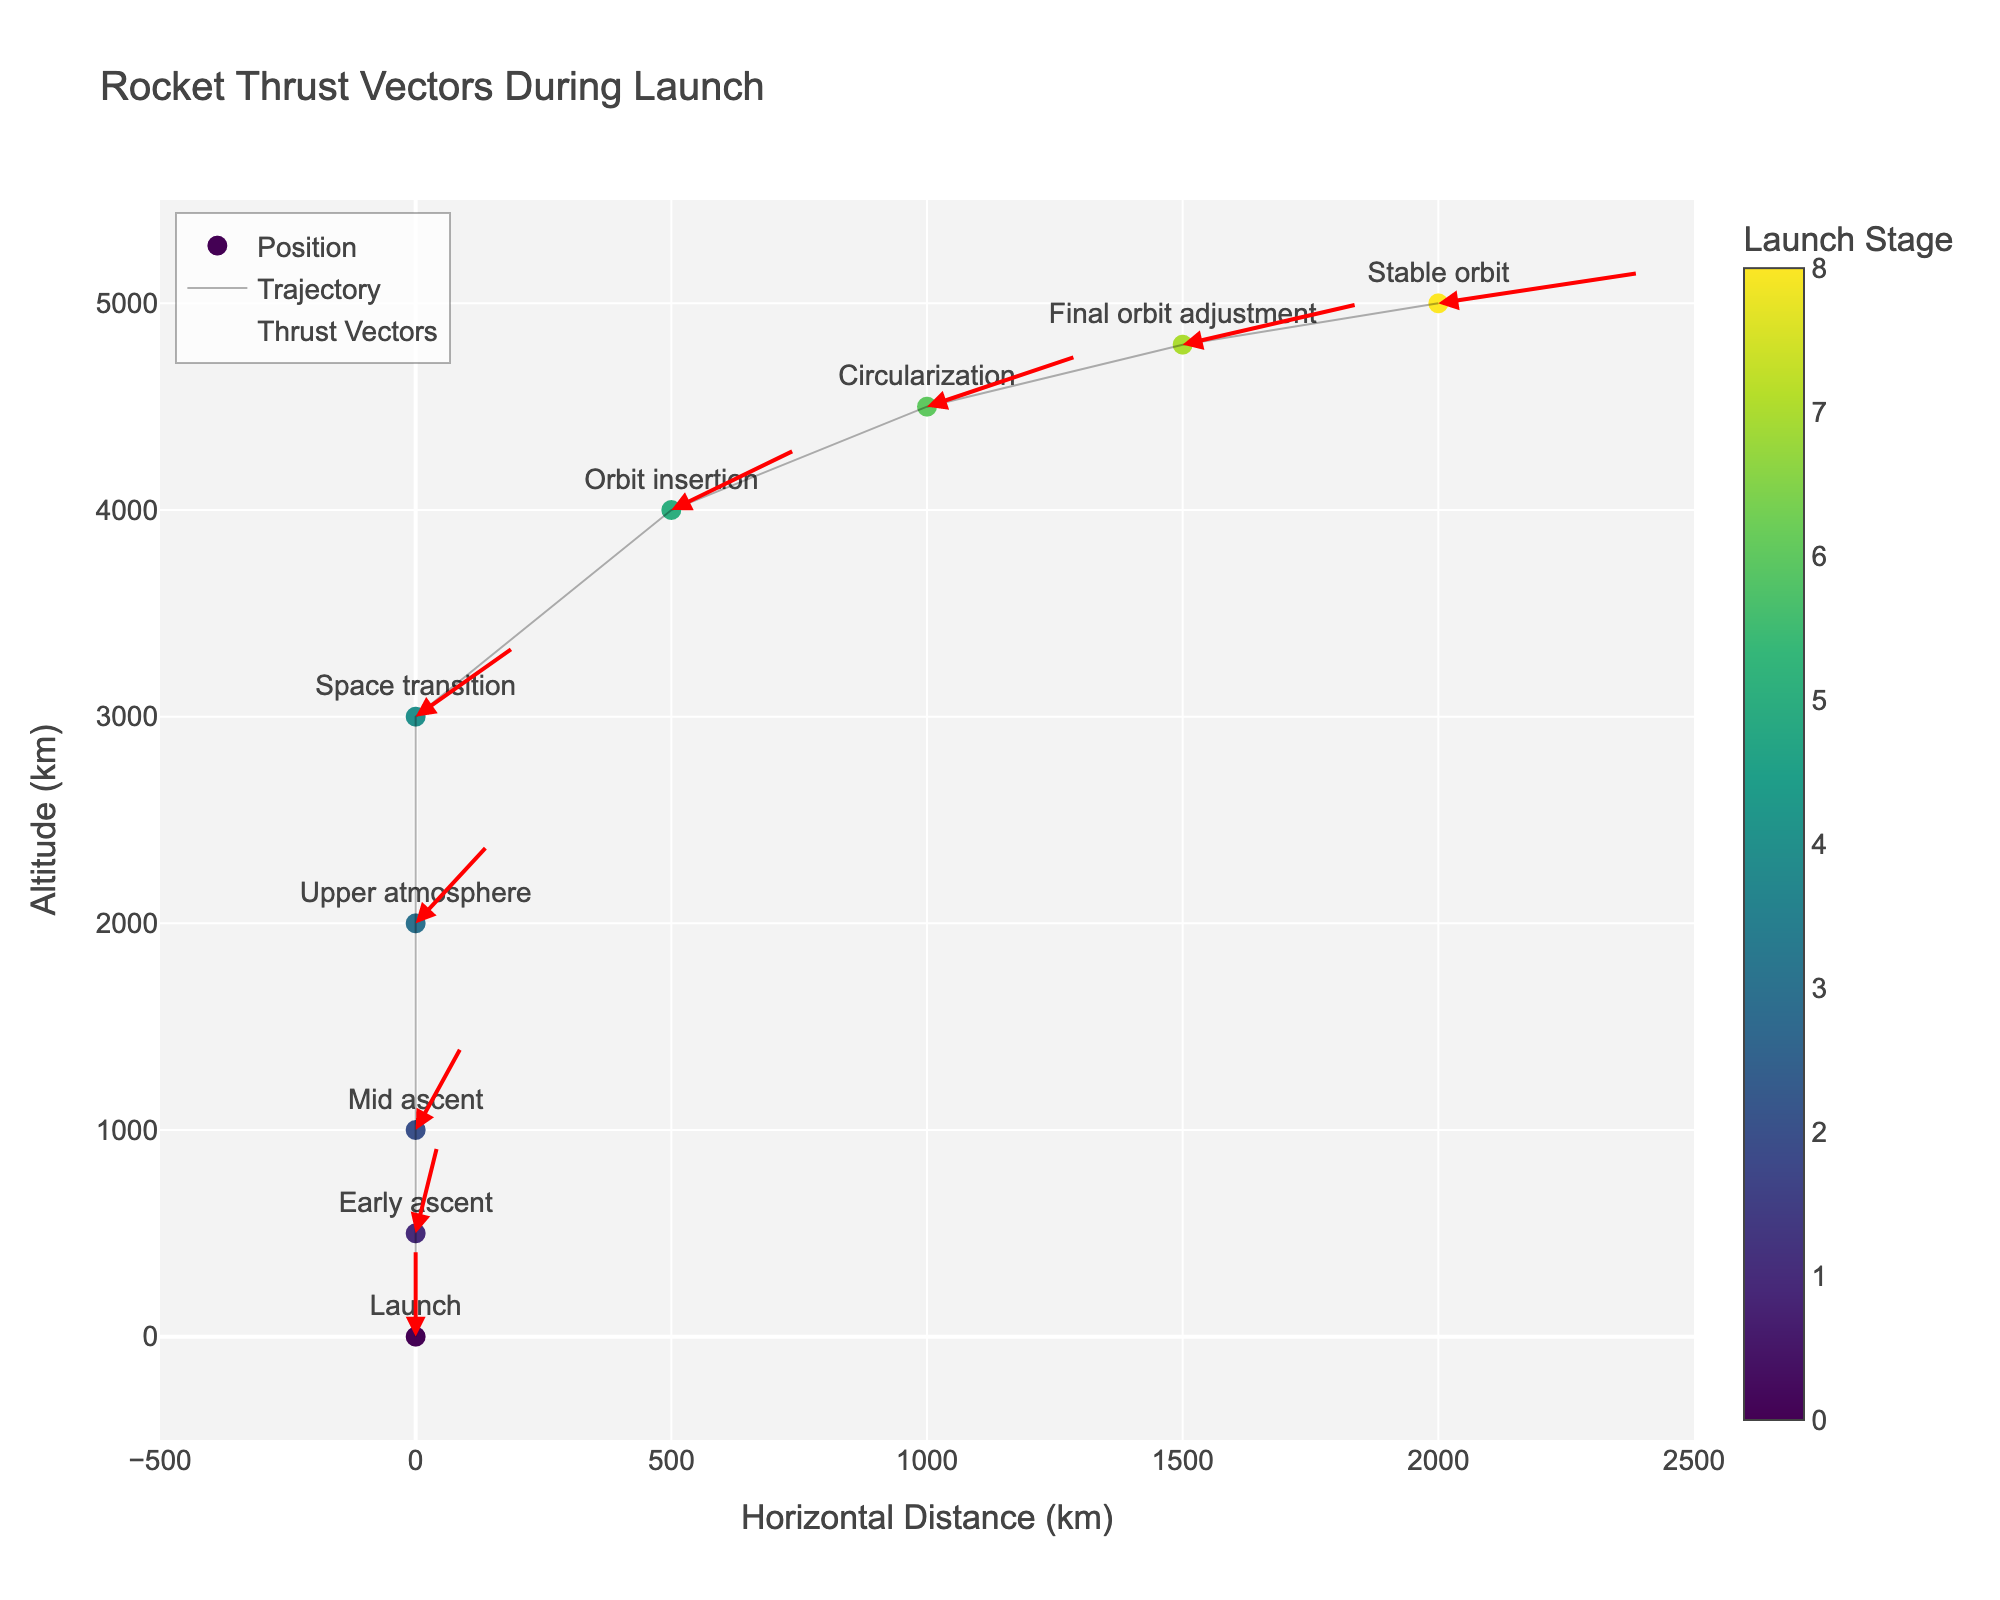What stage corresponds to the label at the highest position on the Y-axis? The highest position on the Y-axis is at 5000 units, which corresponds to the "Stable orbit" stage as per the data points labeled in the figure.
Answer: Stable orbit What is the color of the point representing the 'Final orbit adjustment' stage? Each point is colored according to its index in the data, with colors progressing along the 'Viridis' scale. The point representing 'Final orbit adjustment' should fall around the latter part of the scale, showing a bright color.
Answer: Bright color How does the direction of the thrust vector change from 'Launch' to 'Stable orbit'? The thrust vector at 'Launch' is directed vertically upwards. As the stages progress towards 'Stable orbit', the vectors gradually tilt horizontally and later nearly align horizontally by the 'Stable orbit' stage.
Answer: From vertical to nearly horizontal Which stage shows the vector with the greatest horizontal component? The horizontal component (u) values are given for each stage. 'Stable orbit' has the highest u-value of 0.8, indicating the greatest horizontal component.
Answer: Stable orbit How many stages are represented in the plot? By counting the distinct stages labeled on the figure, we find there are nine different stages from 'Launch' to 'Stable orbit'.
Answer: Nine At which stage is the thrust vector more balanced between vertical and horizontal components? Balancing between vertical and horizontal components means u and v values are roughly equal. 'Orbit insertion' (u=0.5, v=0.6) shows values close to balance compared to other stages.
Answer: Orbit insertion What is the direction of the thrust vector for the 'Mid ascent' stage? From the given data, 'Mid ascent' shows u=0.2 and v=0.9, which means the thrust vector is directed mostly upwards with a slight tilt to the right.
Answer: Upwards with a slight right tilt Which stage has the shortest thrust vector overall? The overall length of a vector can be compared by calculating the magnitude sqrt(u^2 + v^2) for each stage. 'Early ascent' with u=0.1 and v=1 has the vector length close to 1 which is the shortest among the others.
Answer: Early ascent Rank the stages from the smallest horizontal displacement to the largest. By comparing the x values for each stage, we rank the stages as follows: 'Launch', 'Early ascent', 'Mid ascent', 'Upper atmosphere', 'Space transition', 'Orbit insertion', 'Circularization', 'Final orbit adjustment', 'Stable orbit'.
Answer: Launch, Early ascent, Mid ascent, Upper atmosphere, Space transition, Orbit insertion, Circularization, Final orbit adjustment, Stable orbit 